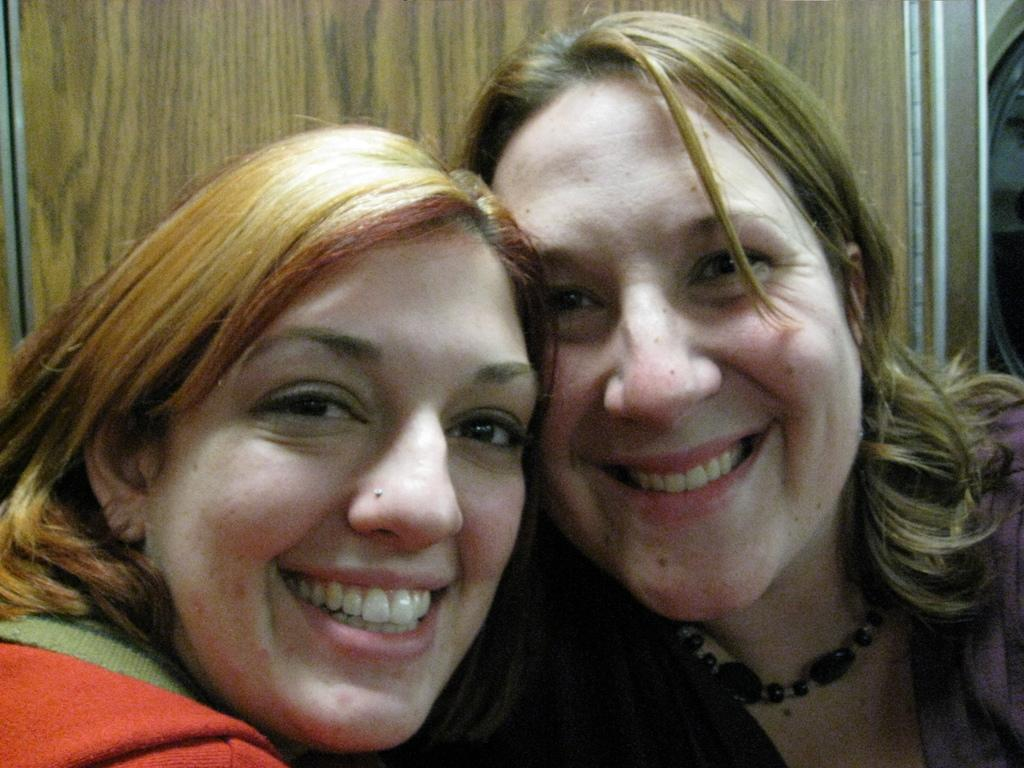How many people are in the image? There are two women in the image. What is the facial expression of the women in the image? The women are smiling. What material might the background of the image be made of? The image appears to be on a wooden board. What type of carriage can be seen in the image? There is no carriage present in the image. What time of day is it in the image? The time of day cannot be determined from the image, as there are no clues or context provided. 